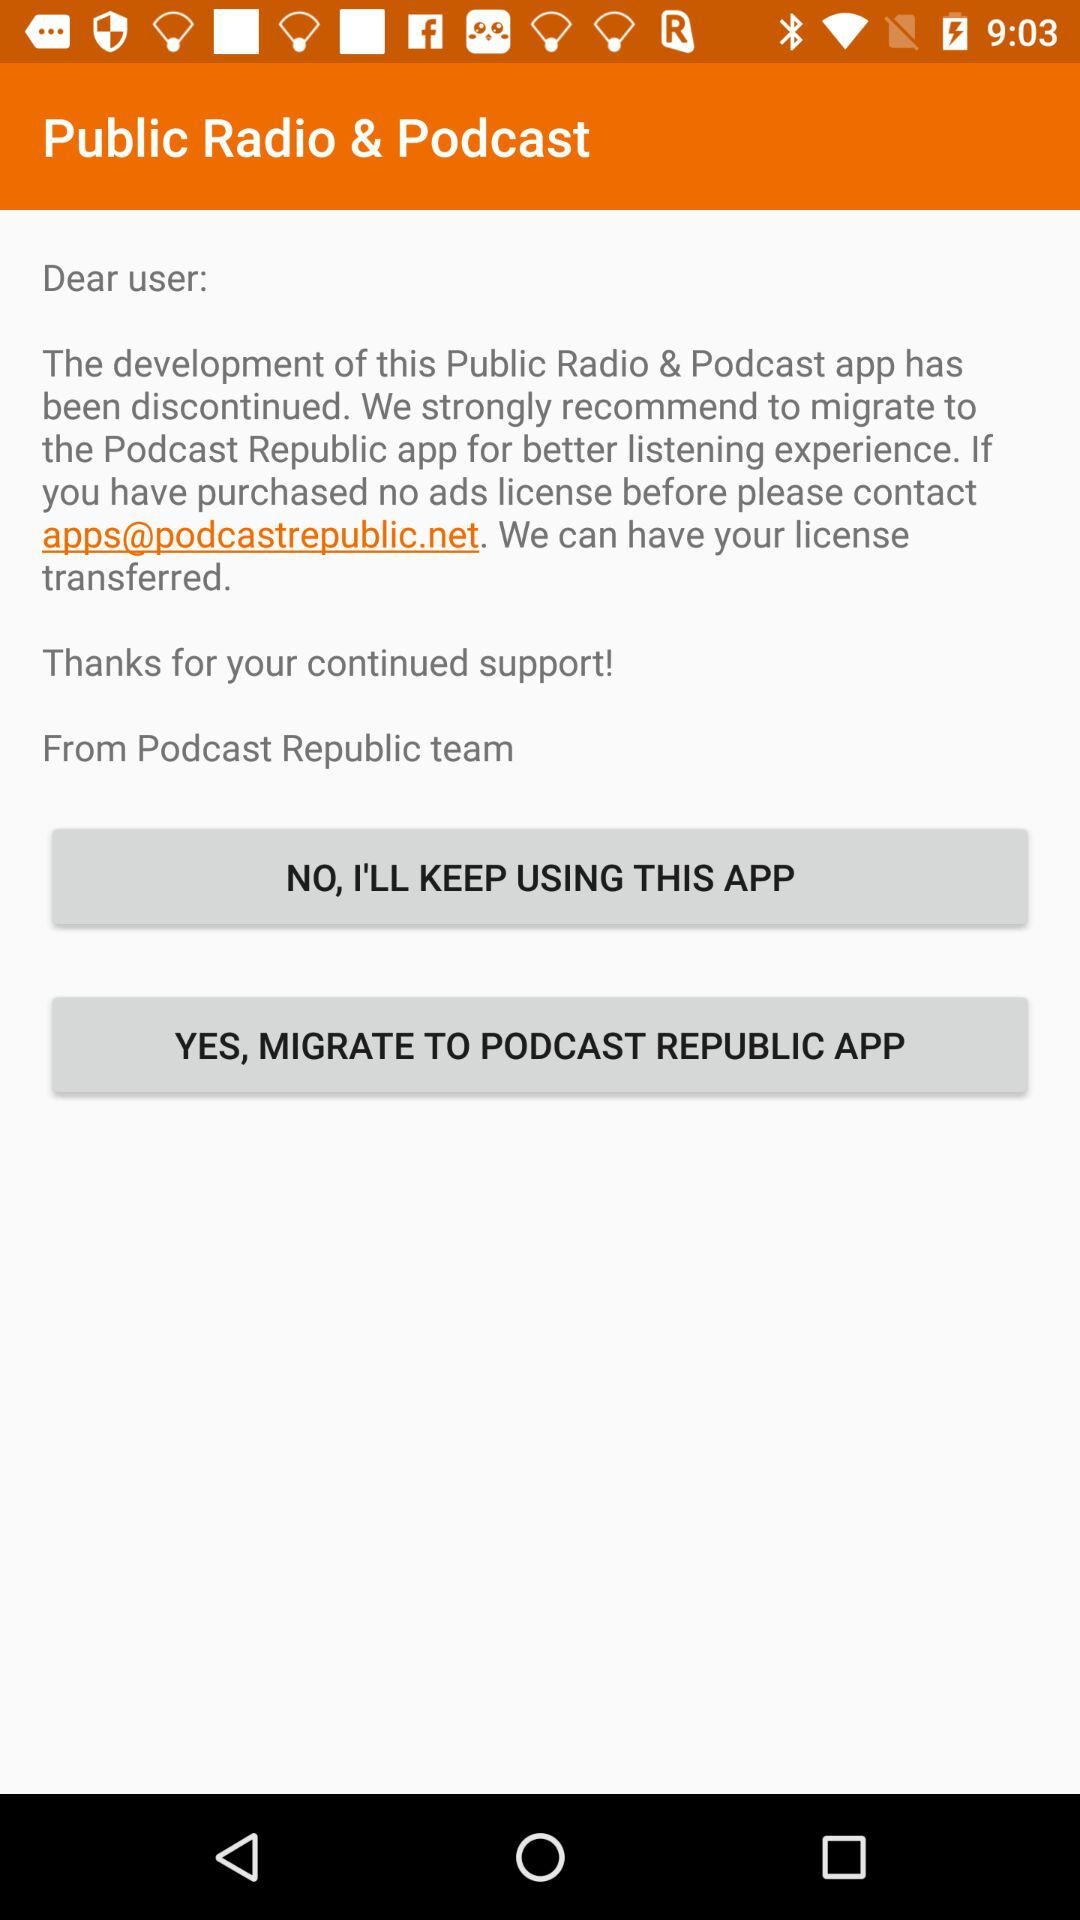What is the email address? The email address is apps@podcastrepublic.net. 